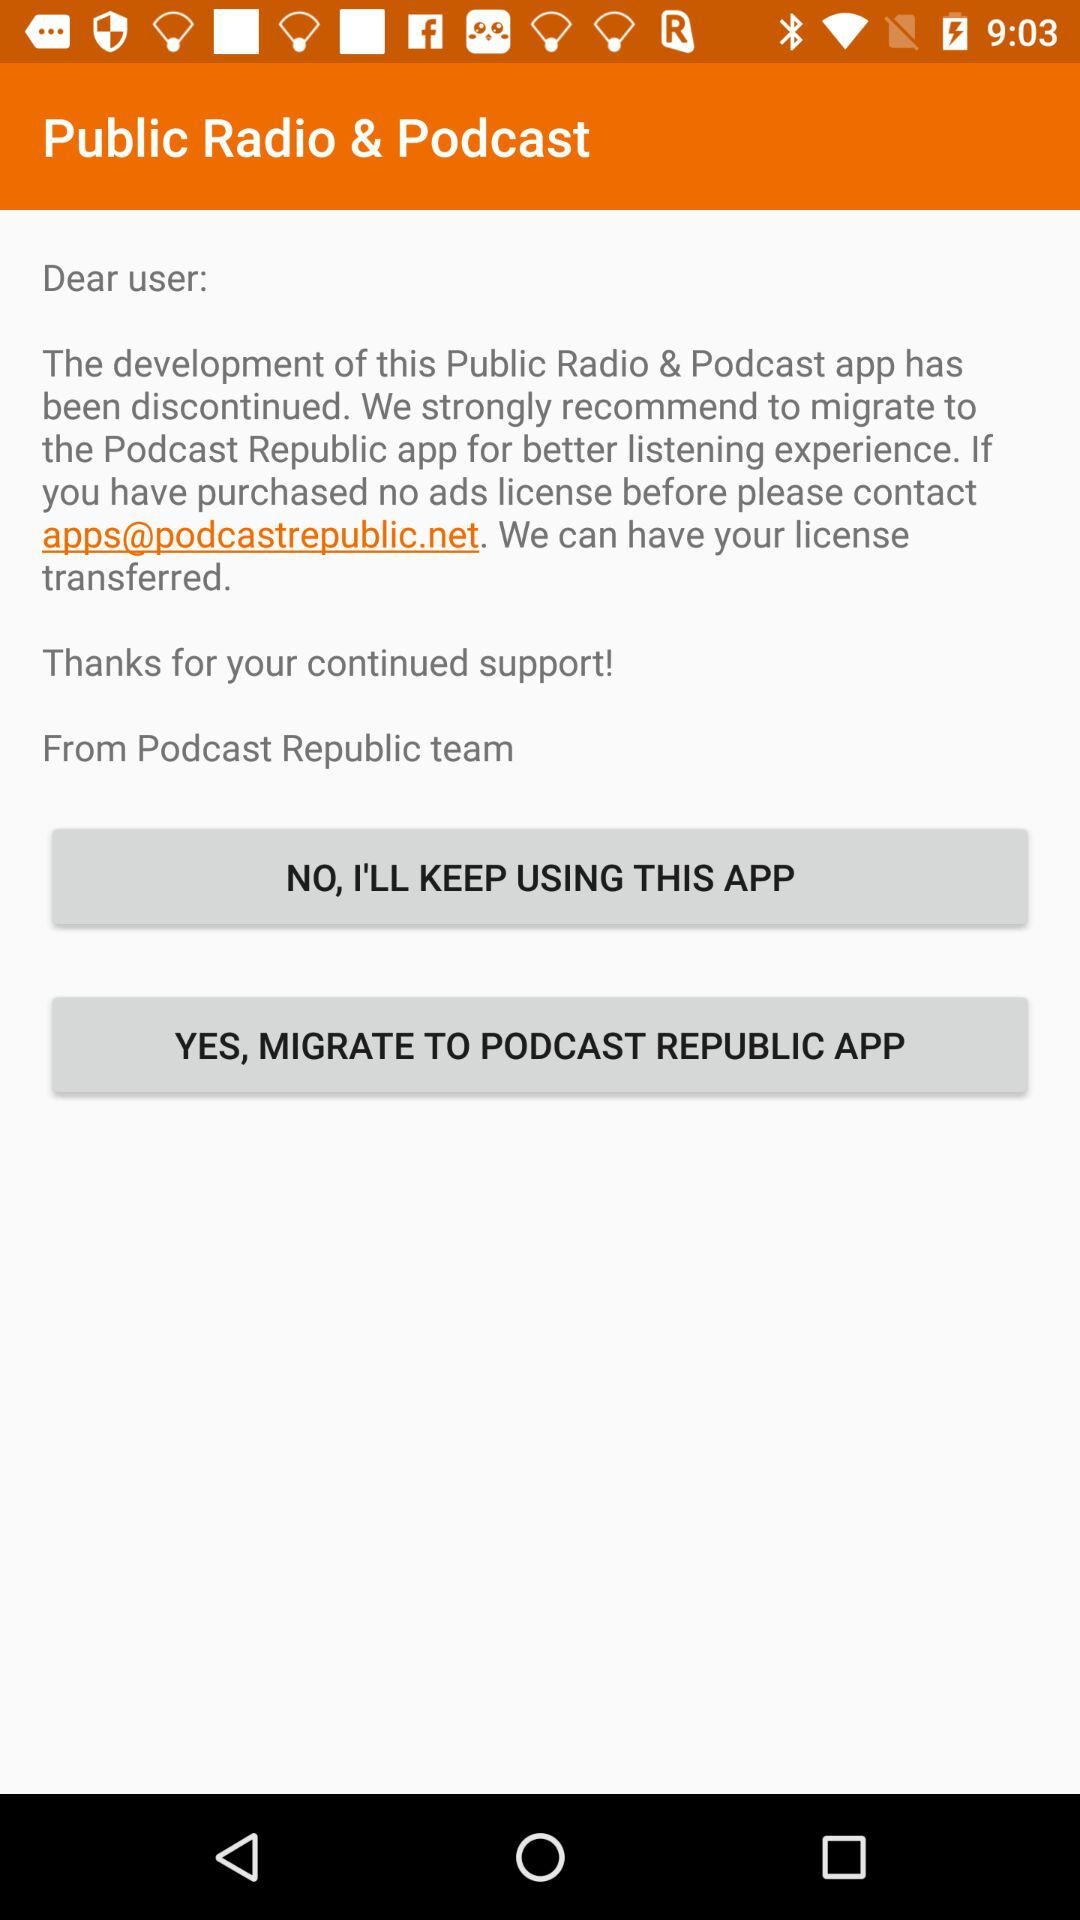What is the email address? The email address is apps@podcastrepublic.net. 